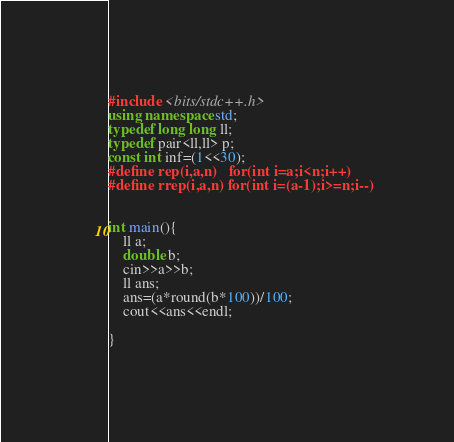<code> <loc_0><loc_0><loc_500><loc_500><_C++_>#include <bits/stdc++.h> 
using namespace std;
typedef long long ll;
typedef pair<ll,ll> p;
const int inf=(1<<30);
#define rep(i,a,n)	for(int i=a;i<n;i++)
#define rrep(i,a,n) for(int i=(a-1);i>=n;i--)
	
	
int main(){
	ll a;
	double b;
	cin>>a>>b;
	ll ans;
	ans=(a*round(b*100))/100;
	cout<<ans<<endl;
	
}</code> 